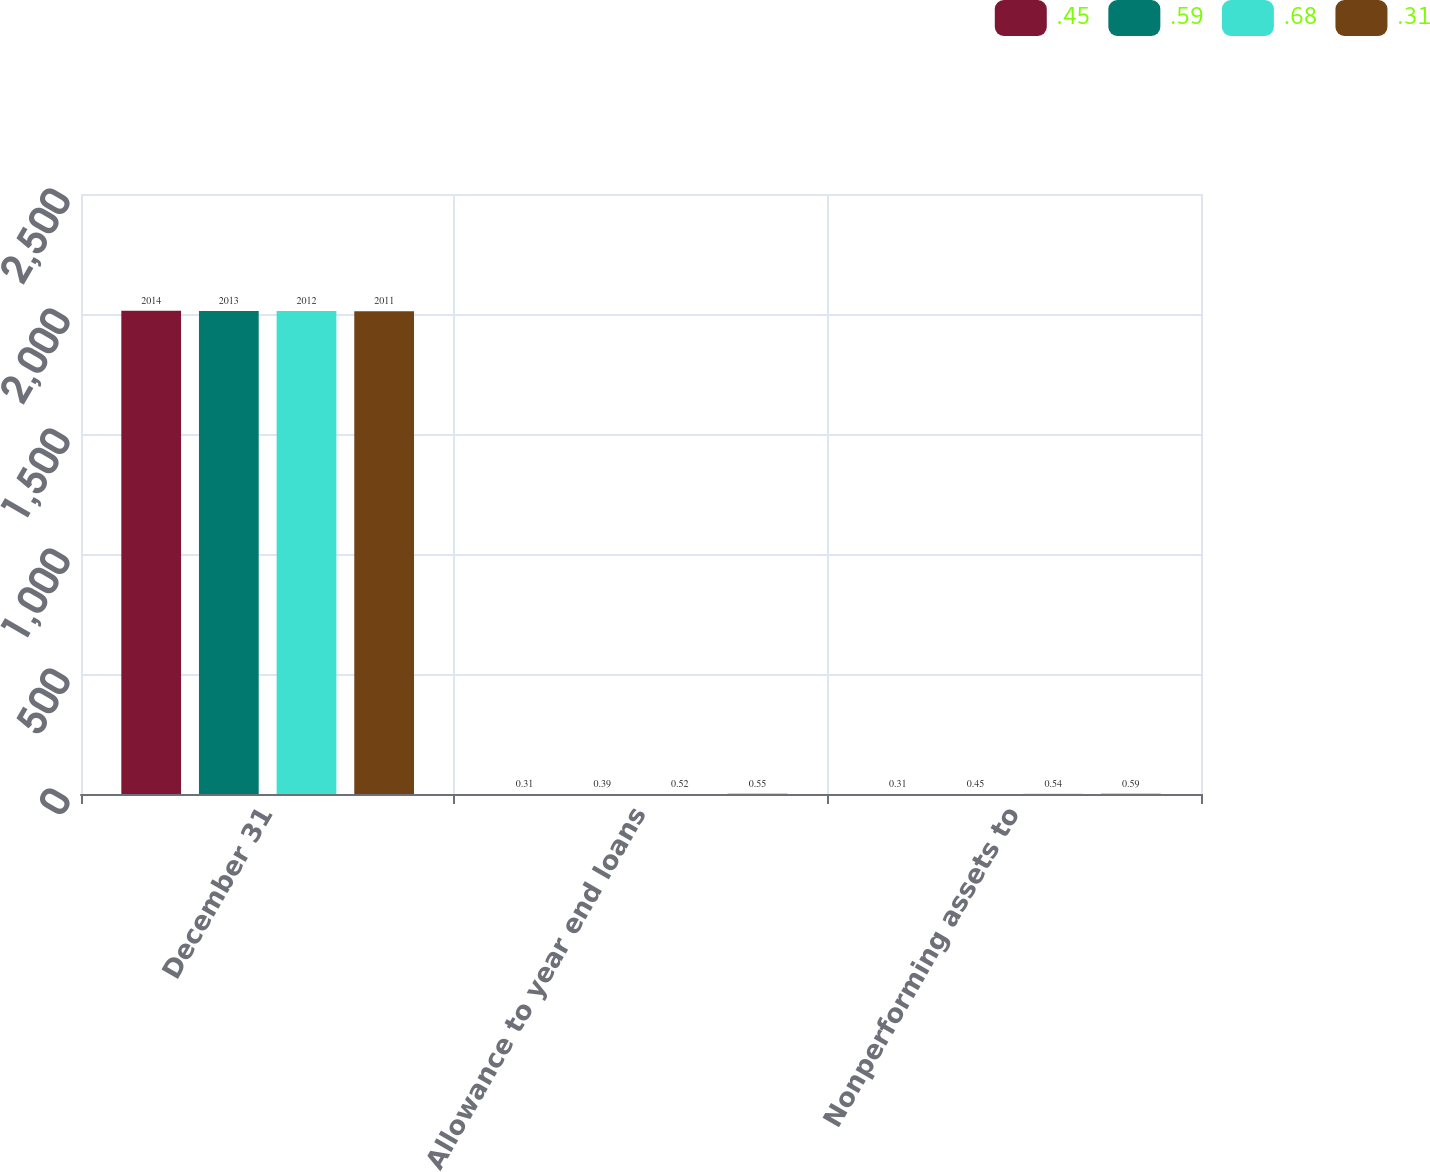<chart> <loc_0><loc_0><loc_500><loc_500><stacked_bar_chart><ecel><fcel>December 31<fcel>Allowance to year end loans<fcel>Nonperforming assets to<nl><fcel>0.45<fcel>2014<fcel>0.31<fcel>0.31<nl><fcel>0.59<fcel>2013<fcel>0.39<fcel>0.45<nl><fcel>0.68<fcel>2012<fcel>0.52<fcel>0.54<nl><fcel>0.31<fcel>2011<fcel>0.55<fcel>0.59<nl></chart> 